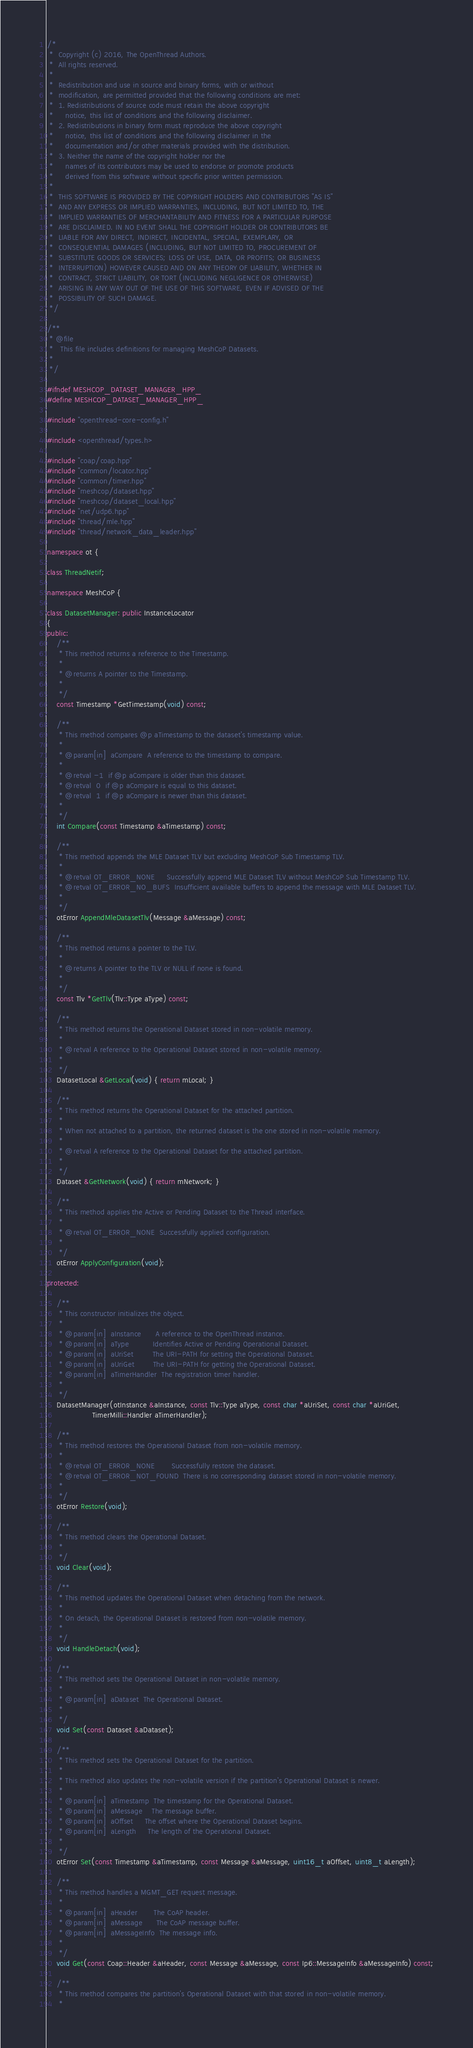<code> <loc_0><loc_0><loc_500><loc_500><_C++_>/*
 *  Copyright (c) 2016, The OpenThread Authors.
 *  All rights reserved.
 *
 *  Redistribution and use in source and binary forms, with or without
 *  modification, are permitted provided that the following conditions are met:
 *  1. Redistributions of source code must retain the above copyright
 *     notice, this list of conditions and the following disclaimer.
 *  2. Redistributions in binary form must reproduce the above copyright
 *     notice, this list of conditions and the following disclaimer in the
 *     documentation and/or other materials provided with the distribution.
 *  3. Neither the name of the copyright holder nor the
 *     names of its contributors may be used to endorse or promote products
 *     derived from this software without specific prior written permission.
 *
 *  THIS SOFTWARE IS PROVIDED BY THE COPYRIGHT HOLDERS AND CONTRIBUTORS "AS IS"
 *  AND ANY EXPRESS OR IMPLIED WARRANTIES, INCLUDING, BUT NOT LIMITED TO, THE
 *  IMPLIED WARRANTIES OF MERCHANTABILITY AND FITNESS FOR A PARTICULAR PURPOSE
 *  ARE DISCLAIMED. IN NO EVENT SHALL THE COPYRIGHT HOLDER OR CONTRIBUTORS BE
 *  LIABLE FOR ANY DIRECT, INDIRECT, INCIDENTAL, SPECIAL, EXEMPLARY, OR
 *  CONSEQUENTIAL DAMAGES (INCLUDING, BUT NOT LIMITED TO, PROCUREMENT OF
 *  SUBSTITUTE GOODS OR SERVICES; LOSS OF USE, DATA, OR PROFITS; OR BUSINESS
 *  INTERRUPTION) HOWEVER CAUSED AND ON ANY THEORY OF LIABILITY, WHETHER IN
 *  CONTRACT, STRICT LIABILITY, OR TORT (INCLUDING NEGLIGENCE OR OTHERWISE)
 *  ARISING IN ANY WAY OUT OF THE USE OF THIS SOFTWARE, EVEN IF ADVISED OF THE
 *  POSSIBILITY OF SUCH DAMAGE.
 */

/**
 * @file
 *   This file includes definitions for managing MeshCoP Datasets.
 *
 */

#ifndef MESHCOP_DATASET_MANAGER_HPP_
#define MESHCOP_DATASET_MANAGER_HPP_

#include "openthread-core-config.h"

#include <openthread/types.h>

#include "coap/coap.hpp"
#include "common/locator.hpp"
#include "common/timer.hpp"
#include "meshcop/dataset.hpp"
#include "meshcop/dataset_local.hpp"
#include "net/udp6.hpp"
#include "thread/mle.hpp"
#include "thread/network_data_leader.hpp"

namespace ot {

class ThreadNetif;

namespace MeshCoP {

class DatasetManager: public InstanceLocator
{
public:
    /**
     * This method returns a reference to the Timestamp.
     *
     * @returns A pointer to the Timestamp.
     *
     */
    const Timestamp *GetTimestamp(void) const;

    /**
     * This method compares @p aTimestamp to the dataset's timestamp value.
     *
     * @param[in]  aCompare  A reference to the timestamp to compare.
     *
     * @retval -1  if @p aCompare is older than this dataset.
     * @retval  0  if @p aCompare is equal to this dataset.
     * @retval  1  if @p aCompare is newer than this dataset.
     *
     */
    int Compare(const Timestamp &aTimestamp) const;

    /**
     * This method appends the MLE Dataset TLV but excluding MeshCoP Sub Timestamp TLV.
     *
     * @retval OT_ERROR_NONE     Successfully append MLE Dataset TLV without MeshCoP Sub Timestamp TLV.
     * @retval OT_ERROR_NO_BUFS  Insufficient available buffers to append the message with MLE Dataset TLV.
     *
     */
    otError AppendMleDatasetTlv(Message &aMessage) const;

    /**
     * This method returns a pointer to the TLV.
     *
     * @returns A pointer to the TLV or NULL if none is found.
     *
     */
    const Tlv *GetTlv(Tlv::Type aType) const;

    /**
     * This method returns the Operational Dataset stored in non-volatile memory.
     *
     * @retval A reference to the Operational Dataset stored in non-volatile memory.
     *
     */
    DatasetLocal &GetLocal(void) { return mLocal; }

    /**
     * This method returns the Operational Dataset for the attached partition.
     *
     * When not attached to a partition, the returned dataset is the one stored in non-volatile memory.
     *
     * @retval A reference to the Operational Dataset for the attached partition.
     *
     */
    Dataset &GetNetwork(void) { return mNetwork; }

    /**
     * This method applies the Active or Pending Dataset to the Thread interface.
     *
     * @retval OT_ERROR_NONE  Successfully applied configuration.
     *
     */
    otError ApplyConfiguration(void);

protected:

    /**
     * This constructor initializes the object.
     *
     * @param[in]  aInstance      A reference to the OpenThread instance.
     * @param[in]  aType          Identifies Active or Pending Operational Dataset.
     * @param[in]  aUriSet        The URI-PATH for setting the Operational Dataset.
     * @param[in]  aUriGet        The URI-PATH for getting the Operational Dataset.
     * @param[in]  aTimerHandler  The registration timer handler.
     *
     */
    DatasetManager(otInstance &aInstance, const Tlv::Type aType, const char *aUriSet, const char *aUriGet,
                   TimerMilli::Handler aTimerHandler);

    /**
     * This method restores the Operational Dataset from non-volatile memory.
     *
     * @retval OT_ERROR_NONE       Successfully restore the dataset.
     * @retval OT_ERROR_NOT_FOUND  There is no corresponding dataset stored in non-volatile memory.
     *
     */
    otError Restore(void);

    /**
     * This method clears the Operational Dataset.
     *
     */
    void Clear(void);

    /**
     * This method updates the Operational Dataset when detaching from the network.
     *
     * On detach, the Operational Dataset is restored from non-volatile memory.
     *
     */
    void HandleDetach(void);

    /**
     * This method sets the Operational Dataset in non-volatile memory.
     *
     * @param[in]  aDataset  The Operational Dataset.
     *
     */
    void Set(const Dataset &aDataset);

    /**
     * This method sets the Operational Dataset for the partition.
     *
     * This method also updates the non-volatile version if the partition's Operational Dataset is newer.
     *
     * @param[in]  aTimestamp  The timestamp for the Operational Dataset.
     * @param[in]  aMessage    The message buffer.
     * @param[in]  aOffset     The offset where the Operational Dataset begins.
     * @param[in]  aLength     The length of the Operational Dataset.
     *
     */
    otError Set(const Timestamp &aTimestamp, const Message &aMessage, uint16_t aOffset, uint8_t aLength);

    /**
     * This method handles a MGMT_GET request message.
     *
     * @param[in]  aHeader       The CoAP header.
     * @param[in]  aMessage      The CoAP message buffer.
     * @param[in]  aMessageInfo  The message info.
     *
     */
    void Get(const Coap::Header &aHeader, const Message &aMessage, const Ip6::MessageInfo &aMessageInfo) const;

    /**
     * This method compares the partition's Operational Dataset with that stored in non-volatile memory.
     *</code> 